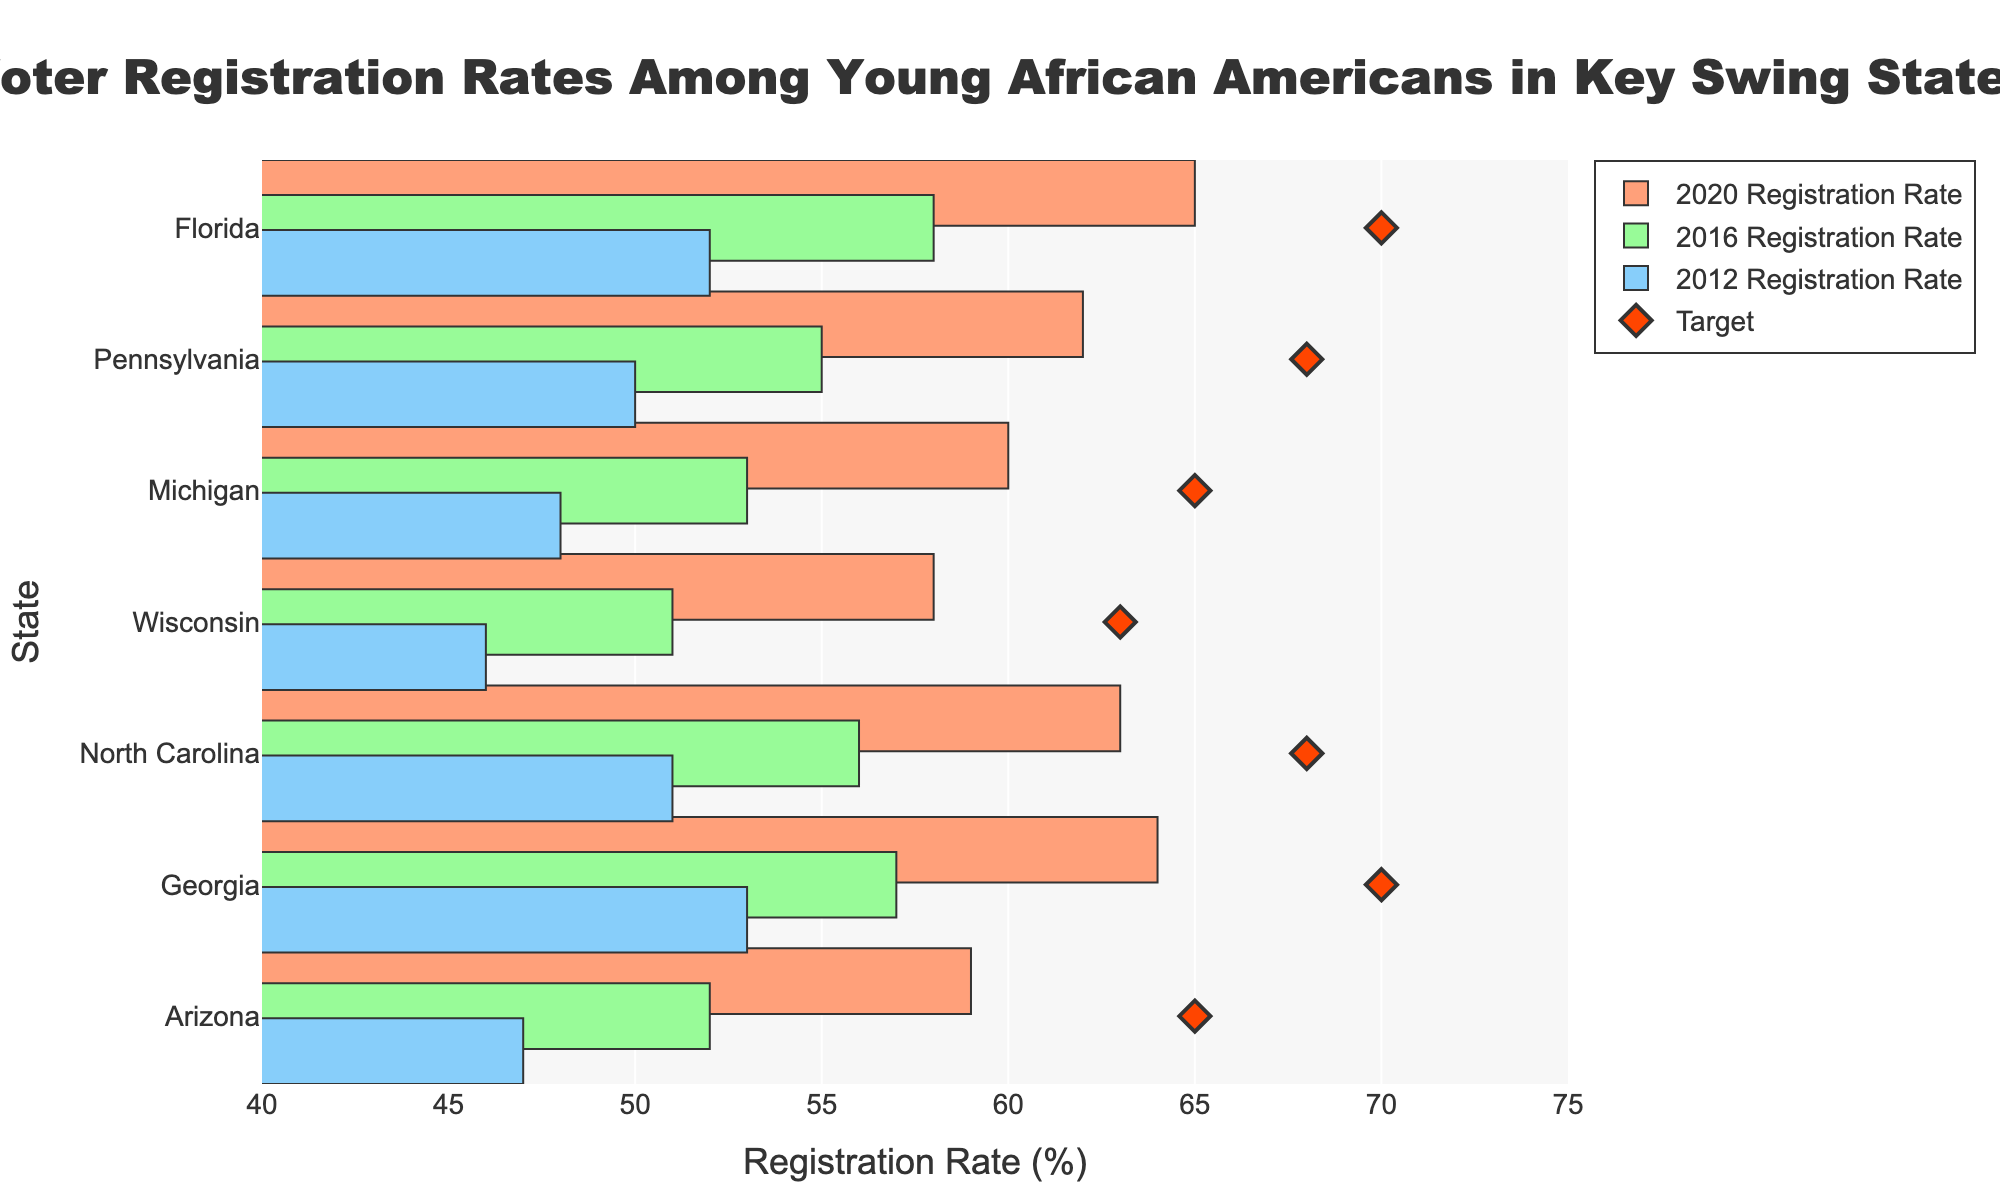What is the title of the figure? The title is located at the top of the figure and reads "Voter Registration Rates Among Young African Americans in Key Swing States."
Answer: Voter Registration Rates Among Young African Americans in Key Swing States How many swing states are illustrated in the figure? By counting the number of states listed on the vertical axis, we find seven swing states.
Answer: Seven Which state had the highest voter registration rate among young African Americans in 2020? By looking at the lengths of the bars for the 2020 Registration Rate, Florida has the highest bar with a rate of 65%.
Answer: Florida What is the target voter registration rate for Georgia? The target rates are marked by diamond symbols. For Georgia, the diamond symbol lines up with 70% on the horizontal axis.
Answer: 70% How much did the voter registration rate increase in Pennsylvania from 2012 to 2020? The 2012 rate for Pennsylvania is 50%, and the 2020 rate is 62%. The increase is calculated by subtracting 50% from 62%, resulting in a 12% increase.
Answer: 12% Which state had the largest increase in voter registration rates from 2012 to 2020? By calculating the difference between the 2020 and 2012 rates for each state, Georgia has the largest increase: 64% (2020) - 53% (2012) = 11%.
Answer: Georgia How many states have 2020 voter registration rates that meet or exceed their targets? Florida (65%, target 70), Pennsylvania (62%, target 68), Michigan (60%, target 65), Wisconsin (58%, target 63), North Carolina (63%, target 68), Georgia (64%, target 70), and Arizona (59%, target 65) are all below their targets. Thus, 0 states meet or exceed their targets.
Answer: 0 Which year shows the lowest voter registration rate for Wisconsin and what is that rate? Wisconsin's lowest rate is seen in 2012, with a rate of 46%.
Answer: 46% What is the average voter registration rate in 2020 for the seven states? Sum the 2020 rates: 65 + 62 + 60 + 58 + 63 + 64 + 59 = 431, then divide by 7 to get the average, which is 431 / 7 ≈ 61.57%.
Answer: 61.57% Has any state reached its voter registration target in 2020? By comparing the 2020 bar lengths with the diamond markers, none of the states have met their target registration rates for 2020.
Answer: No 